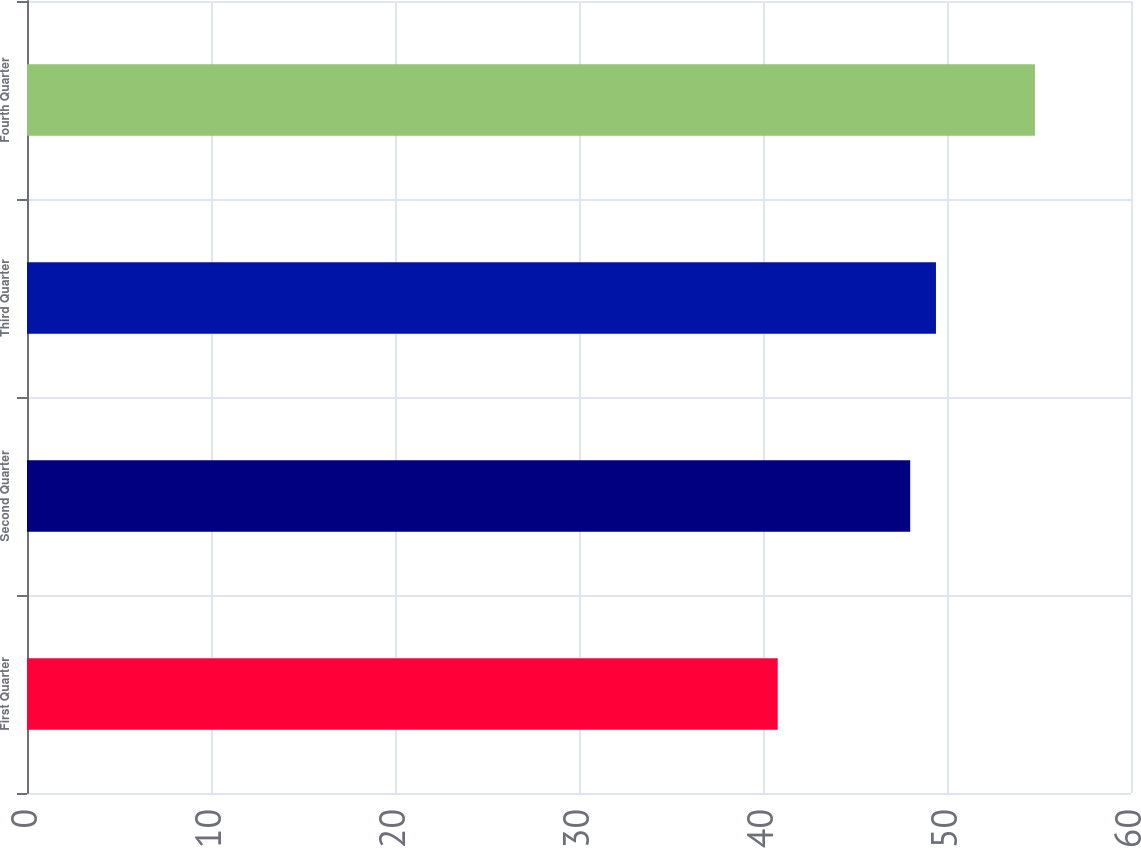Convert chart to OTSL. <chart><loc_0><loc_0><loc_500><loc_500><bar_chart><fcel>First Quarter<fcel>Second Quarter<fcel>Third Quarter<fcel>Fourth Quarter<nl><fcel>40.8<fcel>48<fcel>49.4<fcel>54.78<nl></chart> 